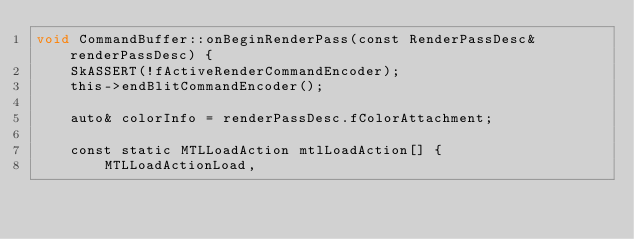Convert code to text. <code><loc_0><loc_0><loc_500><loc_500><_ObjectiveC_>void CommandBuffer::onBeginRenderPass(const RenderPassDesc& renderPassDesc) {
    SkASSERT(!fActiveRenderCommandEncoder);
    this->endBlitCommandEncoder();

    auto& colorInfo = renderPassDesc.fColorAttachment;

    const static MTLLoadAction mtlLoadAction[] {
        MTLLoadActionLoad,</code> 